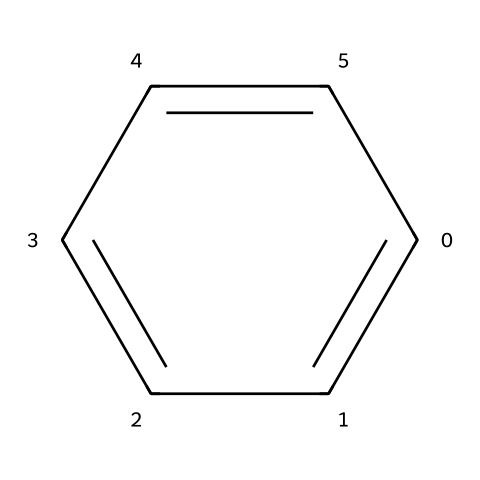What is the molecular formula of this compound? The compound is a benzene derivative, and the SMILES representation shows we have a six-member carbon ring (indicated by 'c') with six hydrogen atoms (inferred from the structure), leading to the molecular formula C6H6.
Answer: C6H6 How many carbon atoms are present in this structure? The SMILES notation 'c1ccccc1' indicates a six-member carbon ring where all atoms are carbon. Therefore, there are six carbon atoms in total.
Answer: 6 What type of bonds are present in this compound? The structure indicates that all the bonds in the benzene ring are aromatic (which includes alternating double bonds), characterizing the compound's stability and distinct properties.
Answer: aromatic bonds Is this compound polar or nonpolar? Due to the symmetrical structure and the presence of only carbon and hydrogen atoms, the compound does not have a significant dipole moment, making it nonpolar.
Answer: nonpolar How many hydrogen atoms are attached to the carbon atoms in this structure? In the benzene ring structure represented by the SMILES, each carbon atom is bonded to one hydrogen atom, resulting in six hydrogen atoms total.
Answer: 6 What kind of pollutants is this compound classified as? Benzene, represented by the given SMILES, is classified as an aromatic hydrocarbon and is known as a volatile organic compound (VOC) often found in oil pollutants.
Answer: VOC What is the relevance of this compound in environmental studies? Benzene is significant in environmental studies due to its toxicity and potential health risks, especially its role as a major contaminant in oil spills and industrial discharges.
Answer: toxicity 